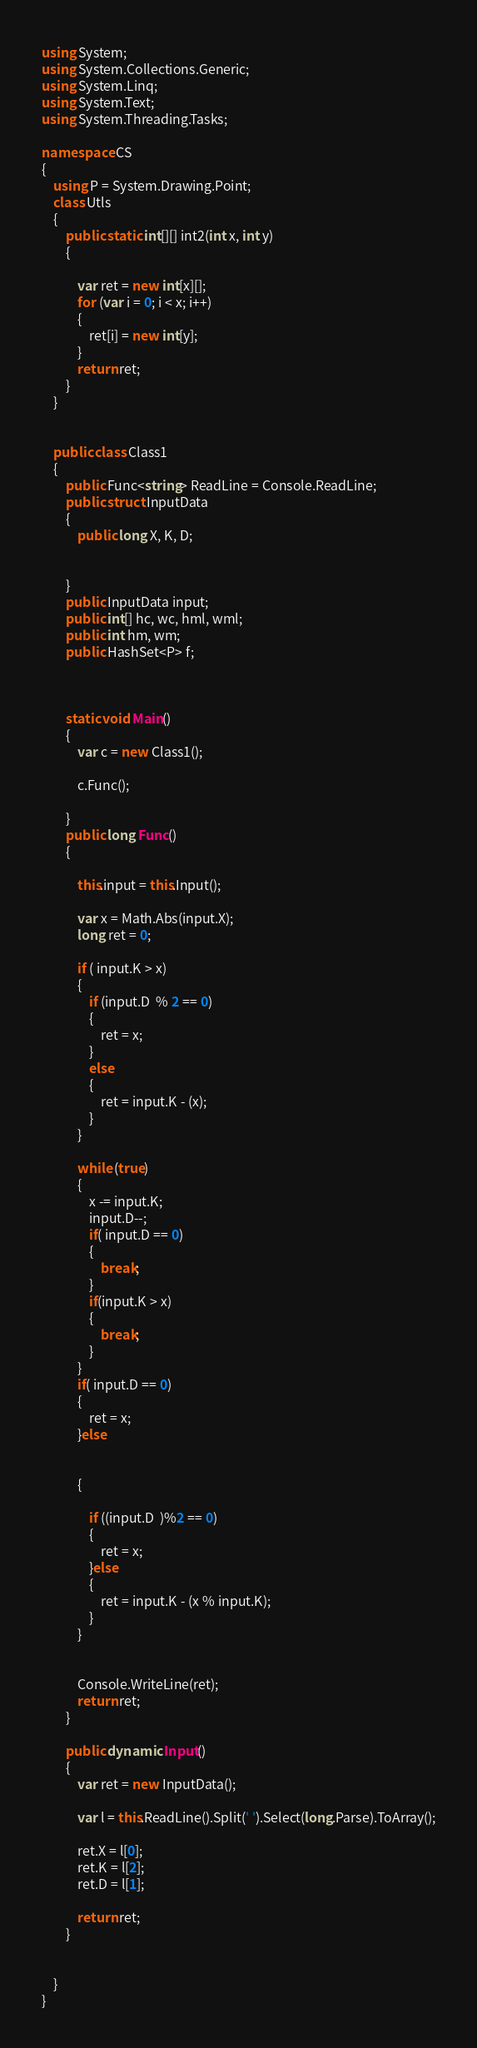<code> <loc_0><loc_0><loc_500><loc_500><_C#_>using System;
using System.Collections.Generic;
using System.Linq;
using System.Text;
using System.Threading.Tasks;

namespace CS
{
    using P = System.Drawing.Point;
    class Utls
    {
        public static int[][] int2(int x, int y)
        {

            var ret = new int[x][];
            for (var i = 0; i < x; i++)
            {
                ret[i] = new int[y];
            }
            return ret;
        }
    }


    public class Class1
    {
        public Func<string> ReadLine = Console.ReadLine;
        public struct InputData
        {
            public long X, K, D;
           

        }
        public InputData input;
        public int[] hc, wc, hml, wml;
        public int hm, wm;
        public HashSet<P> f;



        static void Main()
        {
            var c = new Class1();
           
            c.Func();

        }
        public long Func()
        {

            this.input = this.Input();

            var x = Math.Abs(input.X);
            long ret = 0;
       
            if ( input.K > x)
            {
                if (input.D  % 2 == 0)
                {
                    ret = x;
                }
                else
                {
                    ret = input.K - (x);
                }
            }

            while (true)
            {
                x -= input.K;
                input.D--;
                if( input.D == 0)
                {
                    break;
                }
                if(input.K > x)
                {
                    break;
                }
            }
            if( input.D == 0)
            {
                ret = x;
            }else

          
            {
               
                if ((input.D  )%2 == 0)
                {
                    ret = x;
                }else
                {
                    ret = input.K - (x % input.K);
                }
            }


            Console.WriteLine(ret);
            return ret;
        }

        public dynamic Input()
        {
            var ret = new InputData();

            var l = this.ReadLine().Split(' ').Select(long.Parse).ToArray();

            ret.X = l[0];
            ret.K = l[2];
            ret.D = l[1];

            return ret;
        }


    }
}
</code> 